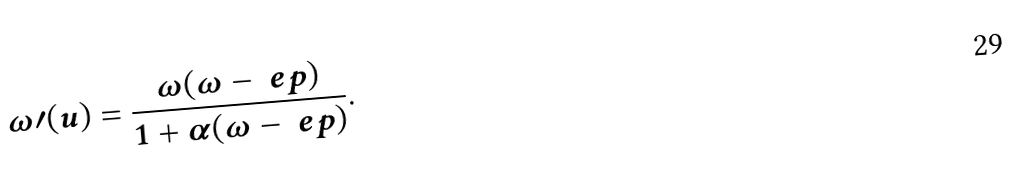Convert formula to latex. <formula><loc_0><loc_0><loc_500><loc_500>\omega \prime ( u ) = \frac { \omega ( \omega - \ e p ) } { 1 + \alpha ( \omega - \ e p ) } .</formula> 